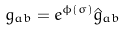<formula> <loc_0><loc_0><loc_500><loc_500>g _ { a b } = e ^ { \phi ( \sigma ) } \hat { g } _ { a b }</formula> 